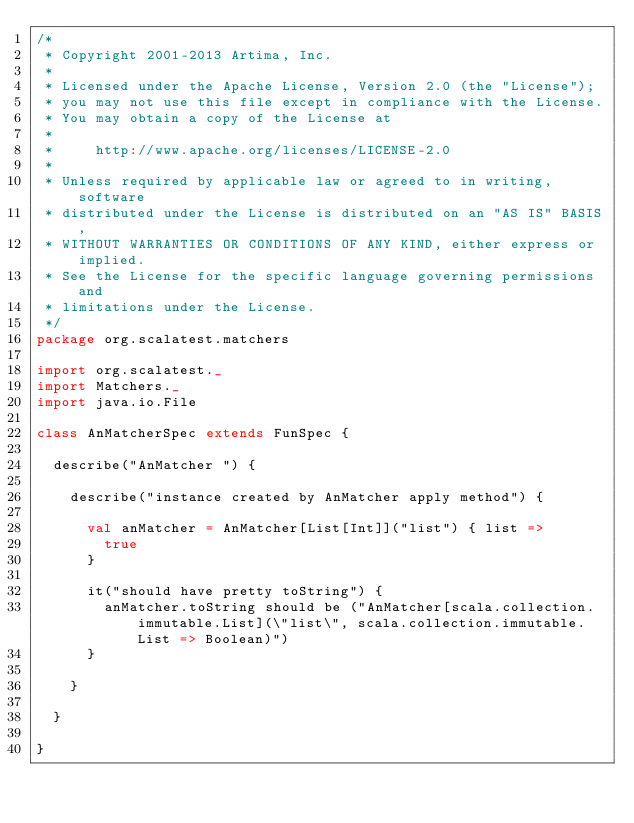<code> <loc_0><loc_0><loc_500><loc_500><_Scala_>/*
 * Copyright 2001-2013 Artima, Inc.
 *
 * Licensed under the Apache License, Version 2.0 (the "License");
 * you may not use this file except in compliance with the License.
 * You may obtain a copy of the License at
 *
 *     http://www.apache.org/licenses/LICENSE-2.0
 *
 * Unless required by applicable law or agreed to in writing, software
 * distributed under the License is distributed on an "AS IS" BASIS,
 * WITHOUT WARRANTIES OR CONDITIONS OF ANY KIND, either express or implied.
 * See the License for the specific language governing permissions and
 * limitations under the License.
 */
package org.scalatest.matchers

import org.scalatest._
import Matchers._
import java.io.File

class AnMatcherSpec extends FunSpec {
  
  describe("AnMatcher ") {
    
    describe("instance created by AnMatcher apply method") {
      
      val anMatcher = AnMatcher[List[Int]]("list") { list =>
        true 
      }
      
      it("should have pretty toString") {
        anMatcher.toString should be ("AnMatcher[scala.collection.immutable.List](\"list\", scala.collection.immutable.List => Boolean)")
      }
      
    }
    
  }
  
}</code> 